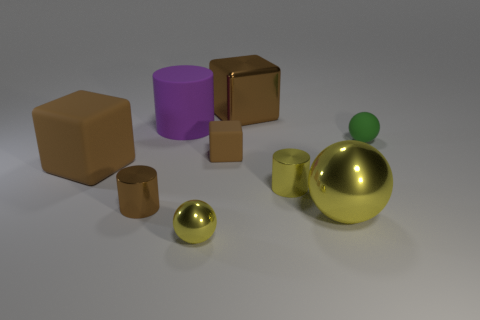Does the large yellow ball have the same material as the small yellow cylinder?
Your answer should be very brief. Yes. There is a object that is behind the tiny yellow shiny ball and in front of the tiny brown cylinder; what shape is it?
Make the answer very short. Sphere. There is another tiny thing that is the same material as the green object; what is its shape?
Ensure brevity in your answer.  Cube. Is there a small cylinder?
Your answer should be very brief. Yes. There is a big cube that is on the right side of the small brown cylinder; are there any large balls behind it?
Offer a terse response. No. There is a yellow object that is the same shape as the large purple object; what is its material?
Offer a terse response. Metal. Is the number of cyan cylinders greater than the number of big blocks?
Offer a very short reply. No. Does the small rubber sphere have the same color as the tiny sphere on the left side of the big brown metallic block?
Your answer should be very brief. No. What color is the cylinder that is both to the left of the small matte cube and in front of the big brown rubber object?
Give a very brief answer. Brown. How many other things are there of the same material as the tiny yellow ball?
Ensure brevity in your answer.  4. 